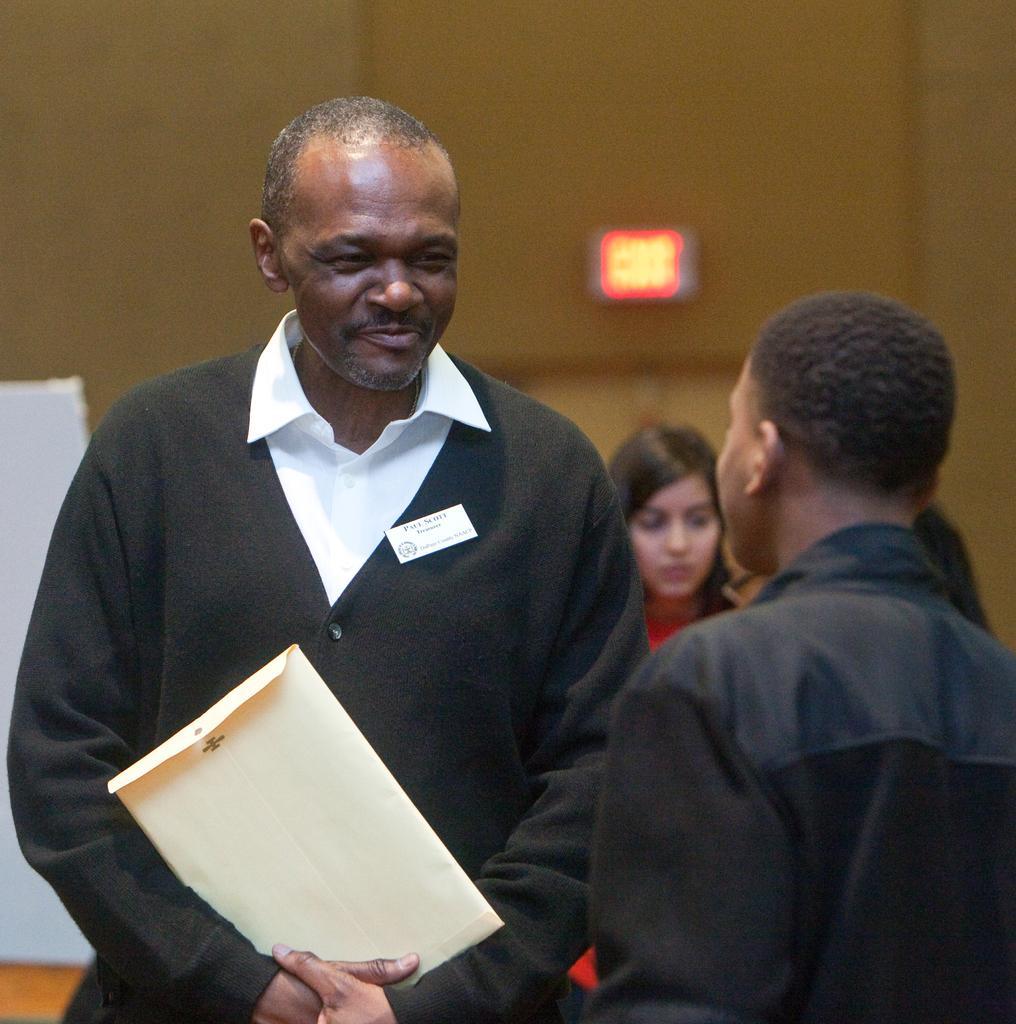How would you summarize this image in a sentence or two? In the image there is a man, he is wearing black coat and holding a cover in his hand and he is looking at the person standing opposite to him and behind the man there is a girl and the background of the man is blur. 